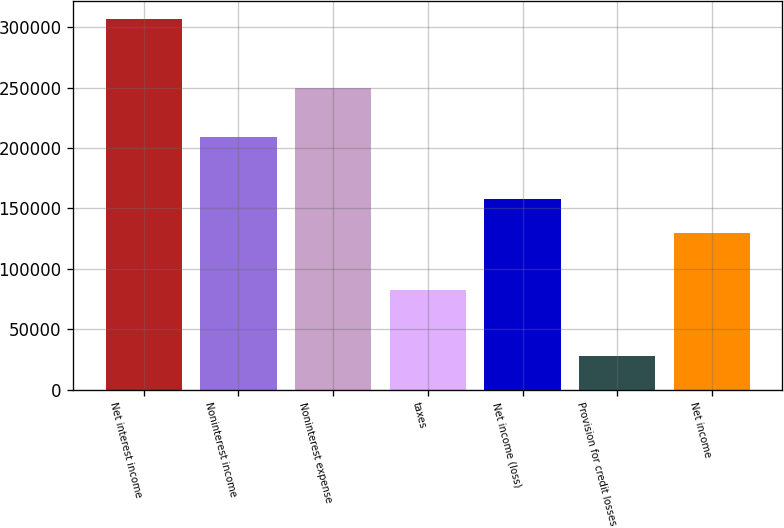<chart> <loc_0><loc_0><loc_500><loc_500><bar_chart><fcel>Net interest income<fcel>Noninterest income<fcel>Noninterest expense<fcel>taxes<fcel>Net income (loss)<fcel>Provision for credit losses<fcel>Net income<nl><fcel>306434<fcel>209238<fcel>249300<fcel>82198<fcel>157859<fcel>27464<fcel>129962<nl></chart> 